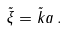Convert formula to latex. <formula><loc_0><loc_0><loc_500><loc_500>\tilde { \xi } = \tilde { k } a \, .</formula> 